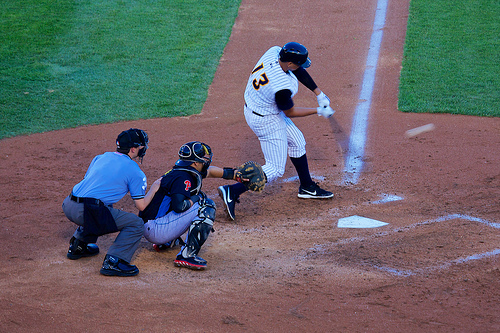Are there any skis or parking meters in the photo? No, there are no skis or parking meters; the setting is a baseball field, focused on the game. 